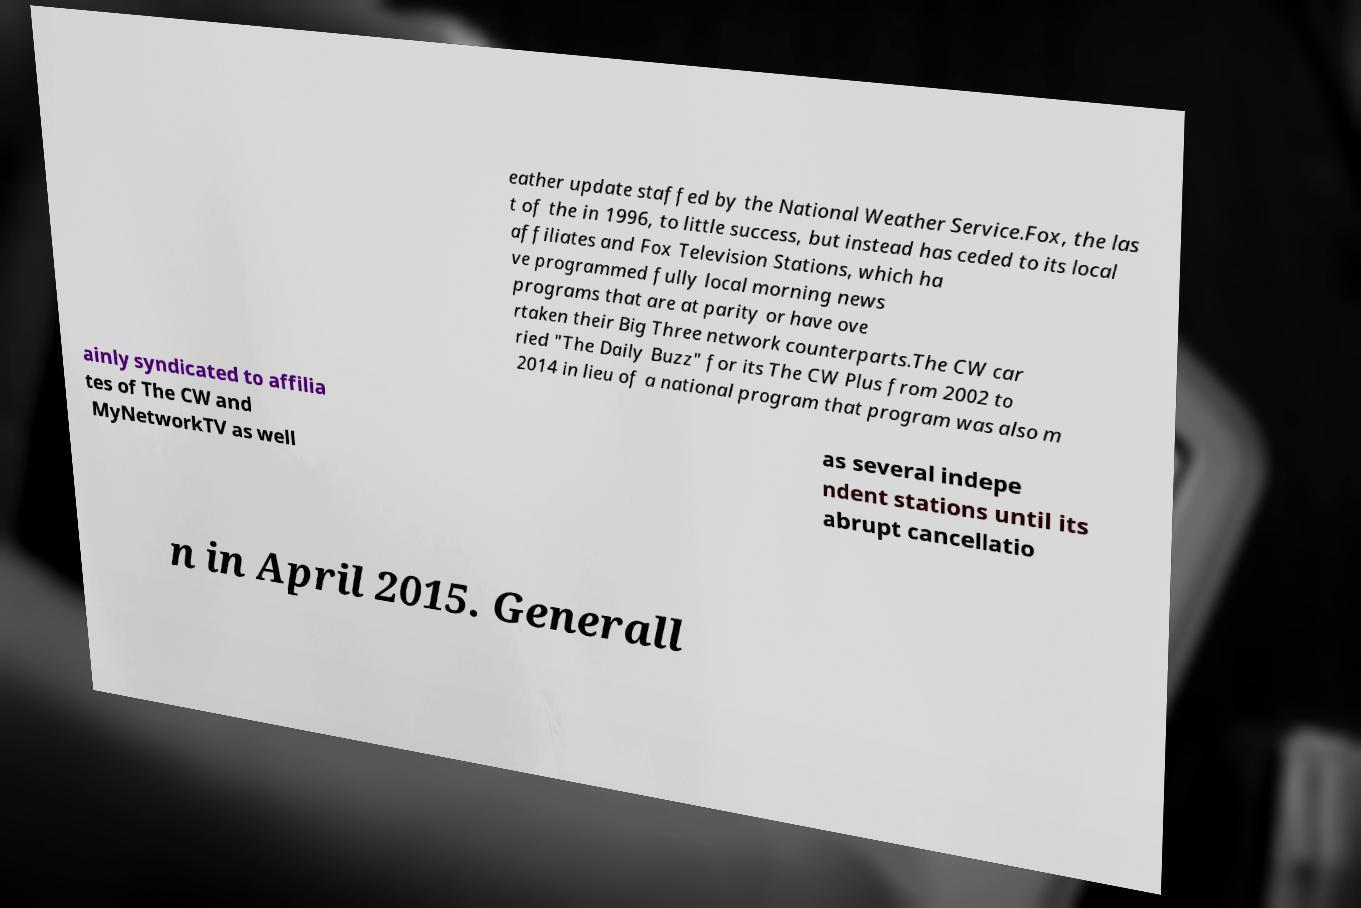For documentation purposes, I need the text within this image transcribed. Could you provide that? eather update staffed by the National Weather Service.Fox, the las t of the in 1996, to little success, but instead has ceded to its local affiliates and Fox Television Stations, which ha ve programmed fully local morning news programs that are at parity or have ove rtaken their Big Three network counterparts.The CW car ried "The Daily Buzz" for its The CW Plus from 2002 to 2014 in lieu of a national program that program was also m ainly syndicated to affilia tes of The CW and MyNetworkTV as well as several indepe ndent stations until its abrupt cancellatio n in April 2015. Generall 